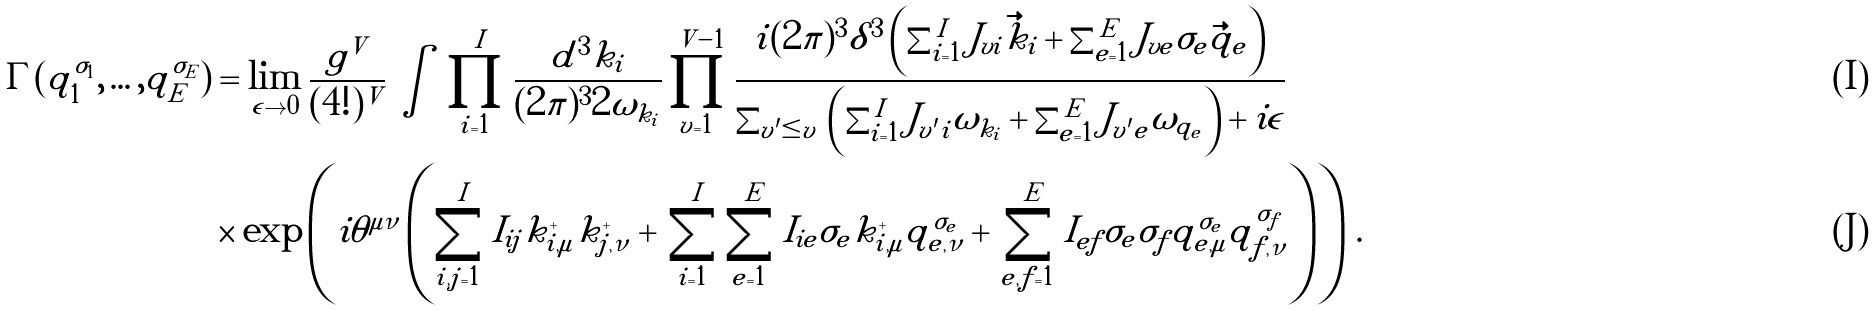<formula> <loc_0><loc_0><loc_500><loc_500>\Gamma ( q _ { 1 } ^ { \sigma _ { 1 } } , \dots , q _ { E } ^ { \sigma _ { E } } ) & = \lim _ { \epsilon \to 0 } \frac { g ^ { V } } { ( 4 ! ) ^ { V } } \, \int \, \prod _ { i = 1 } ^ { I } \frac { d ^ { 3 } k _ { i } } { ( 2 \pi ) ^ { 3 } 2 \omega _ { k _ { i } } } \prod _ { v = 1 } ^ { V - 1 } \frac { i ( 2 \pi ) ^ { 3 } \delta ^ { 3 } \left ( \sum _ { i = 1 } ^ { I } J _ { v i } \vec { k } _ { i } + \sum _ { e = 1 } ^ { E } J _ { v e } \sigma _ { e } \vec { q } _ { e } \right ) } { \sum _ { v ^ { \prime } \leq v } \, \left ( \sum _ { i = 1 } ^ { I } J _ { v ^ { \prime } i } \omega _ { k _ { i } } + \sum _ { e = 1 } ^ { E } J _ { v ^ { \prime } e } \omega _ { q _ { e } } \right ) + i \epsilon } \\ & \times \exp \left ( i \theta ^ { \mu \nu } \left ( \sum _ { i , j = 1 } ^ { I } I _ { i j } k _ { i , \mu } ^ { + } k _ { j , \nu } ^ { + } + \, \sum _ { i = 1 } ^ { I } \sum _ { e = 1 } ^ { E } I _ { i e } \sigma _ { e } k _ { i , \mu } ^ { + } q _ { e , \nu } ^ { \sigma _ { e } } + \, \sum _ { e , f = 1 } ^ { E } I _ { e f } \sigma _ { e } \sigma _ { f } q _ { e , \mu } ^ { \sigma _ { e } } q _ { f , \nu } ^ { \sigma _ { f } } \right ) \right ) \, .</formula> 